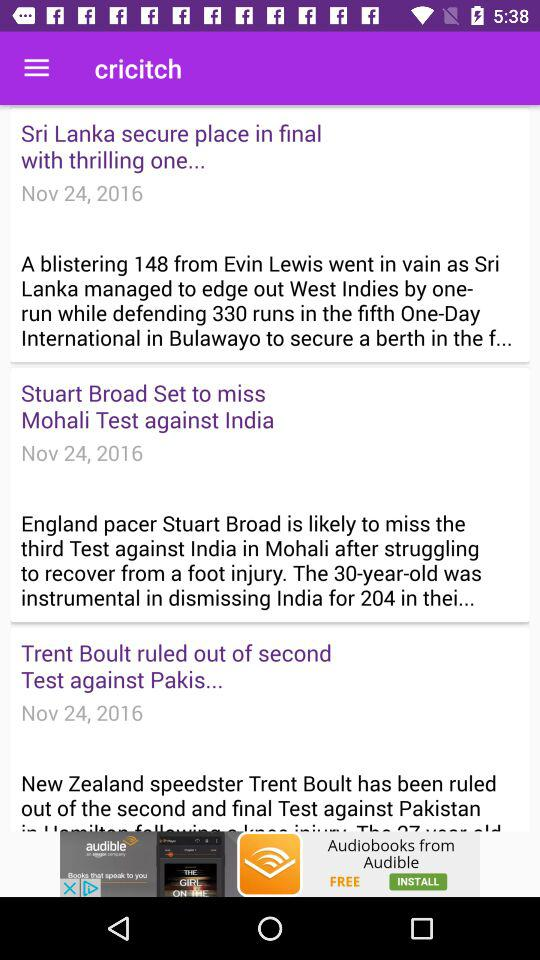What is the venue of the "New Zealand" and "Pakistan" test match? The venue is Seddon Park in Hamilton. 